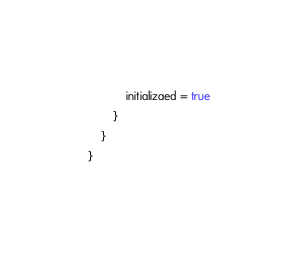Convert code to text. <code><loc_0><loc_0><loc_500><loc_500><_Kotlin_>            initializaed = true
        }
    }
}</code> 